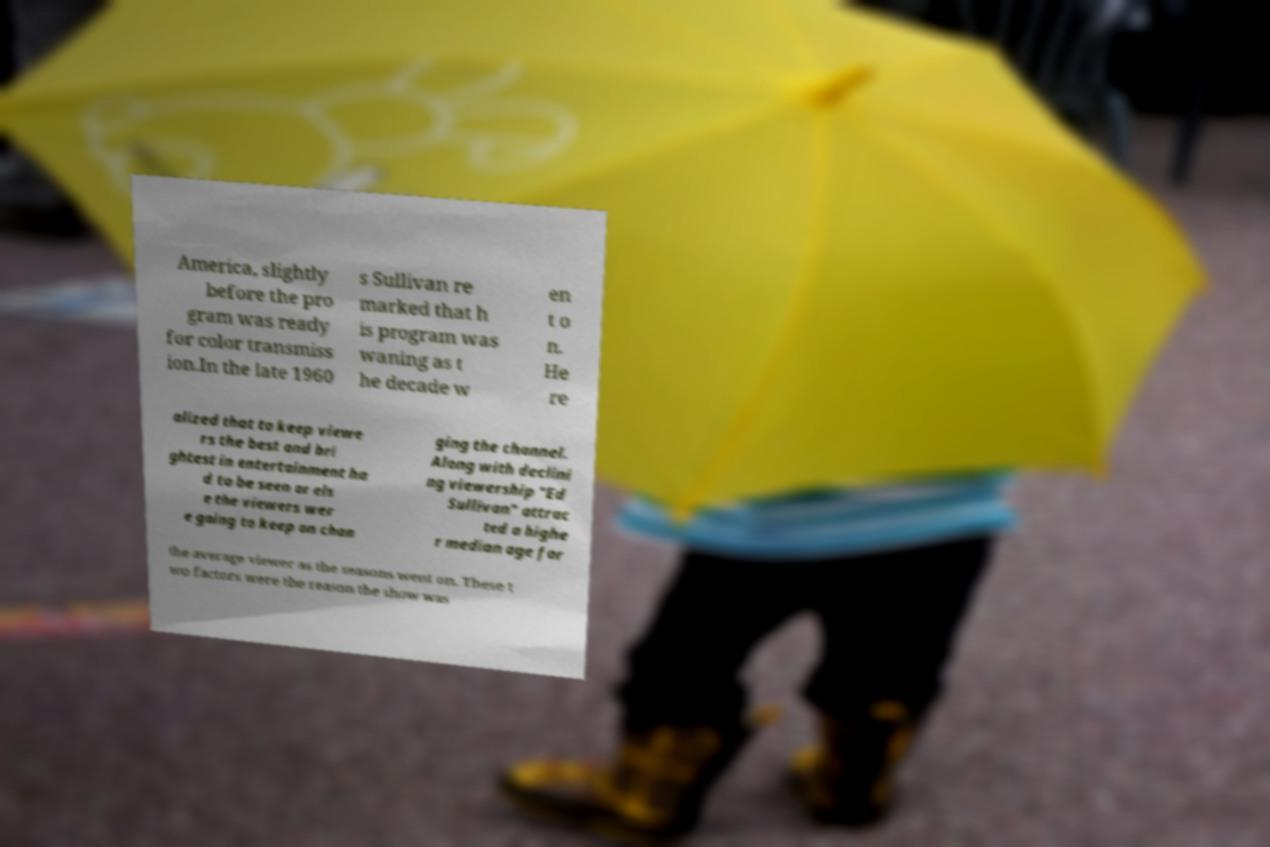For documentation purposes, I need the text within this image transcribed. Could you provide that? America, slightly before the pro gram was ready for color transmiss ion.In the late 1960 s Sullivan re marked that h is program was waning as t he decade w en t o n. He re alized that to keep viewe rs the best and bri ghtest in entertainment ha d to be seen or els e the viewers wer e going to keep on chan ging the channel. Along with declini ng viewership "Ed Sullivan" attrac ted a highe r median age for the average viewer as the seasons went on. These t wo factors were the reason the show was 